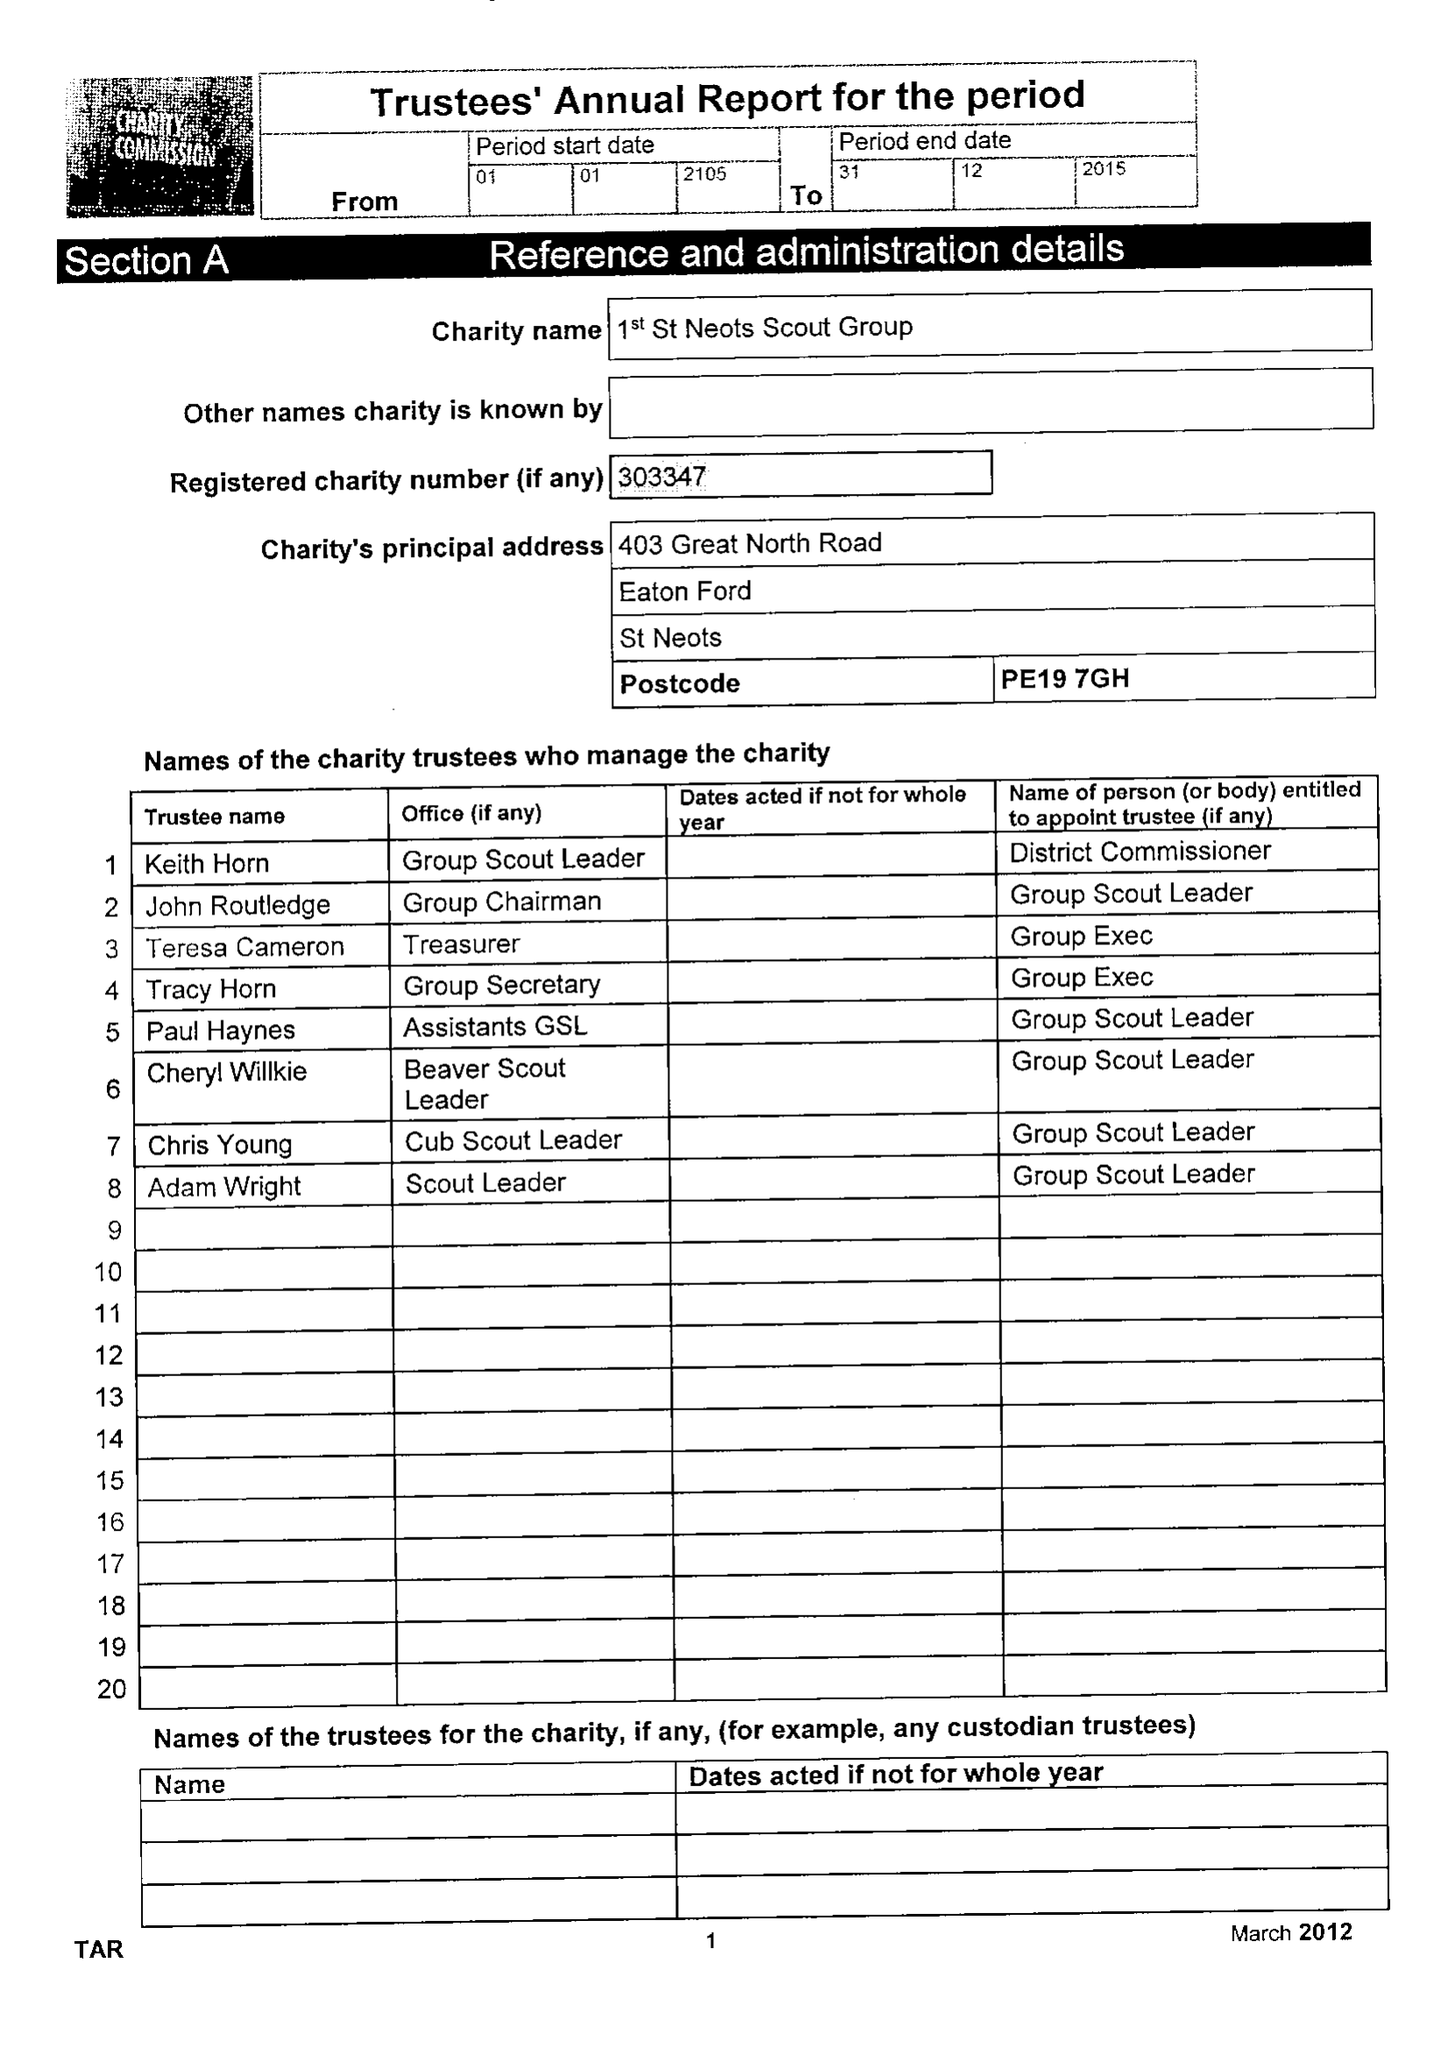What is the value for the charity_number?
Answer the question using a single word or phrase. 303347 